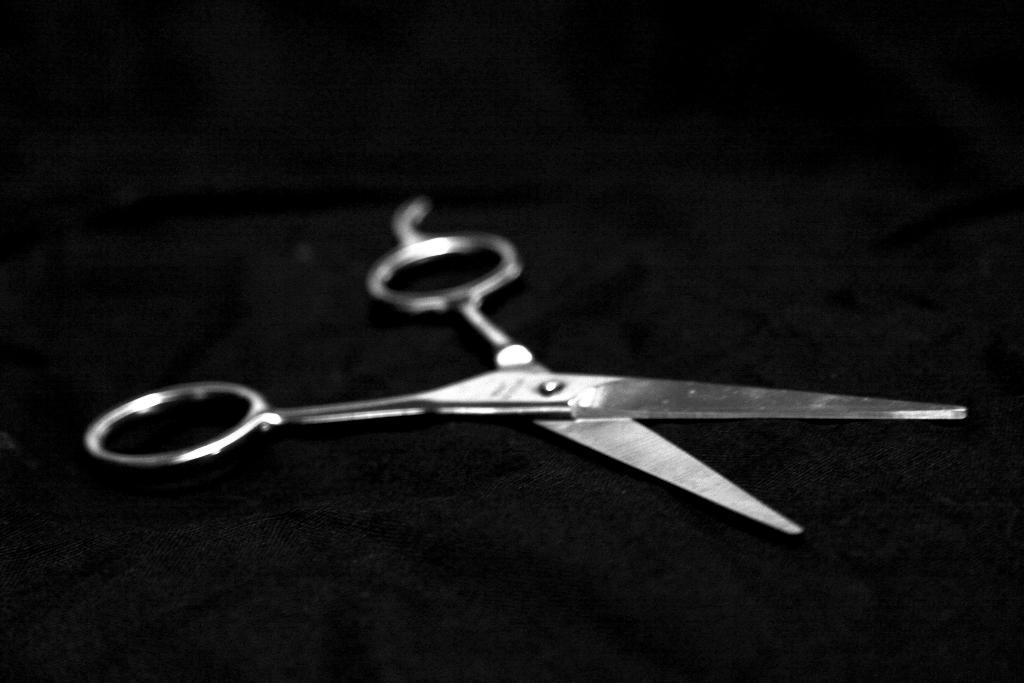What type of object is in the image? There is a metal scissor in the image. What is the scissor placed on? The metal scissor is on a black surface. How many representatives are present in the image? There are no representatives present in the image; it only features a metal scissor on a black surface. 